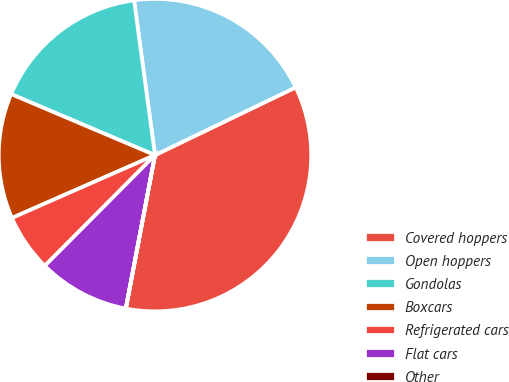Convert chart to OTSL. <chart><loc_0><loc_0><loc_500><loc_500><pie_chart><fcel>Covered hoppers<fcel>Open hoppers<fcel>Gondolas<fcel>Boxcars<fcel>Refrigerated cars<fcel>Flat cars<fcel>Other<nl><fcel>35.12%<fcel>19.99%<fcel>16.48%<fcel>12.97%<fcel>5.95%<fcel>9.46%<fcel>0.02%<nl></chart> 